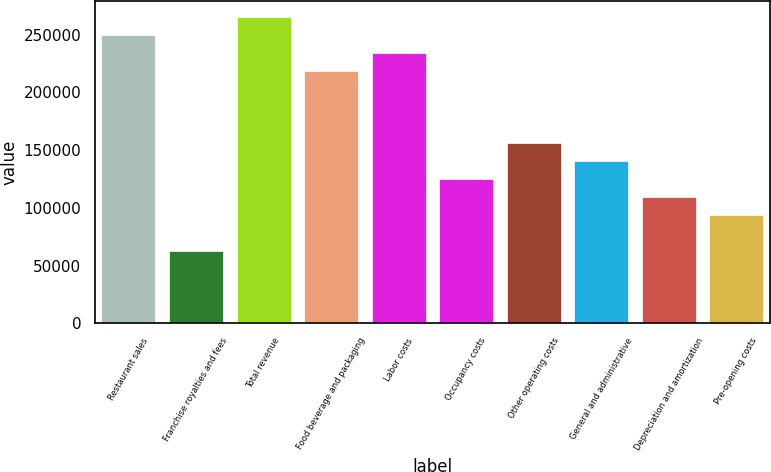Convert chart. <chart><loc_0><loc_0><loc_500><loc_500><bar_chart><fcel>Restaurant sales<fcel>Franchise royalties and fees<fcel>Total revenue<fcel>Food beverage and packaging<fcel>Labor costs<fcel>Occupancy costs<fcel>Other operating costs<fcel>General and administrative<fcel>Depreciation and amortization<fcel>Pre-opening costs<nl><fcel>250111<fcel>62528.9<fcel>265743<fcel>218847<fcel>234479<fcel>125056<fcel>156320<fcel>140688<fcel>109424<fcel>93792.6<nl></chart> 